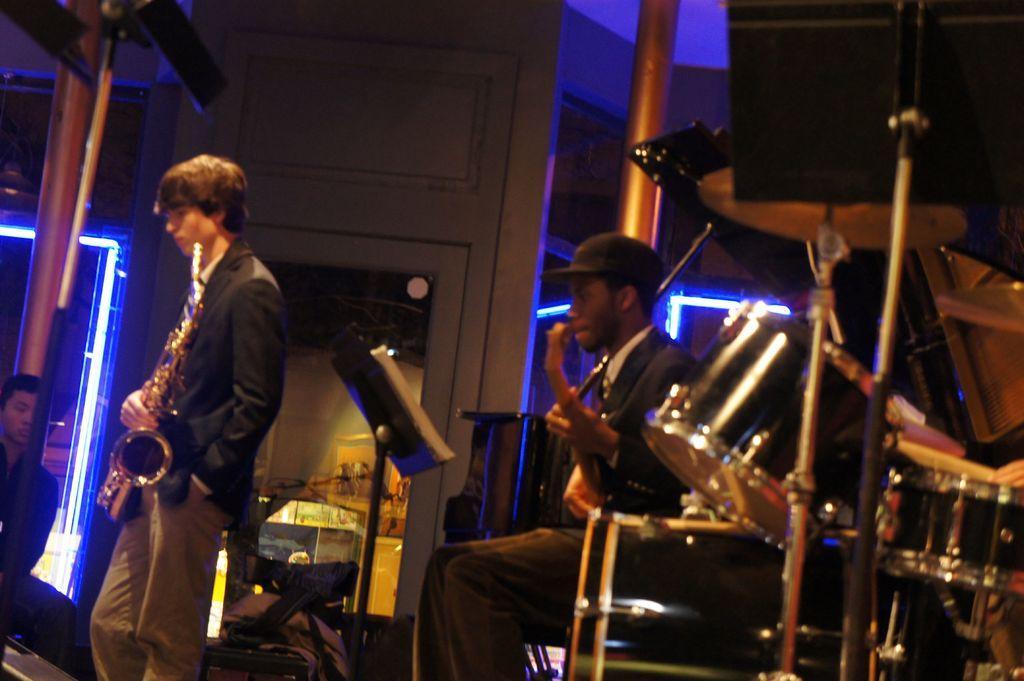Can you describe this image briefly? In this image, we can see persons wearing clothes and playing musical instruments. There are musical drums in the bottom right of the image. There is a light on the left and in the middle of the image. 